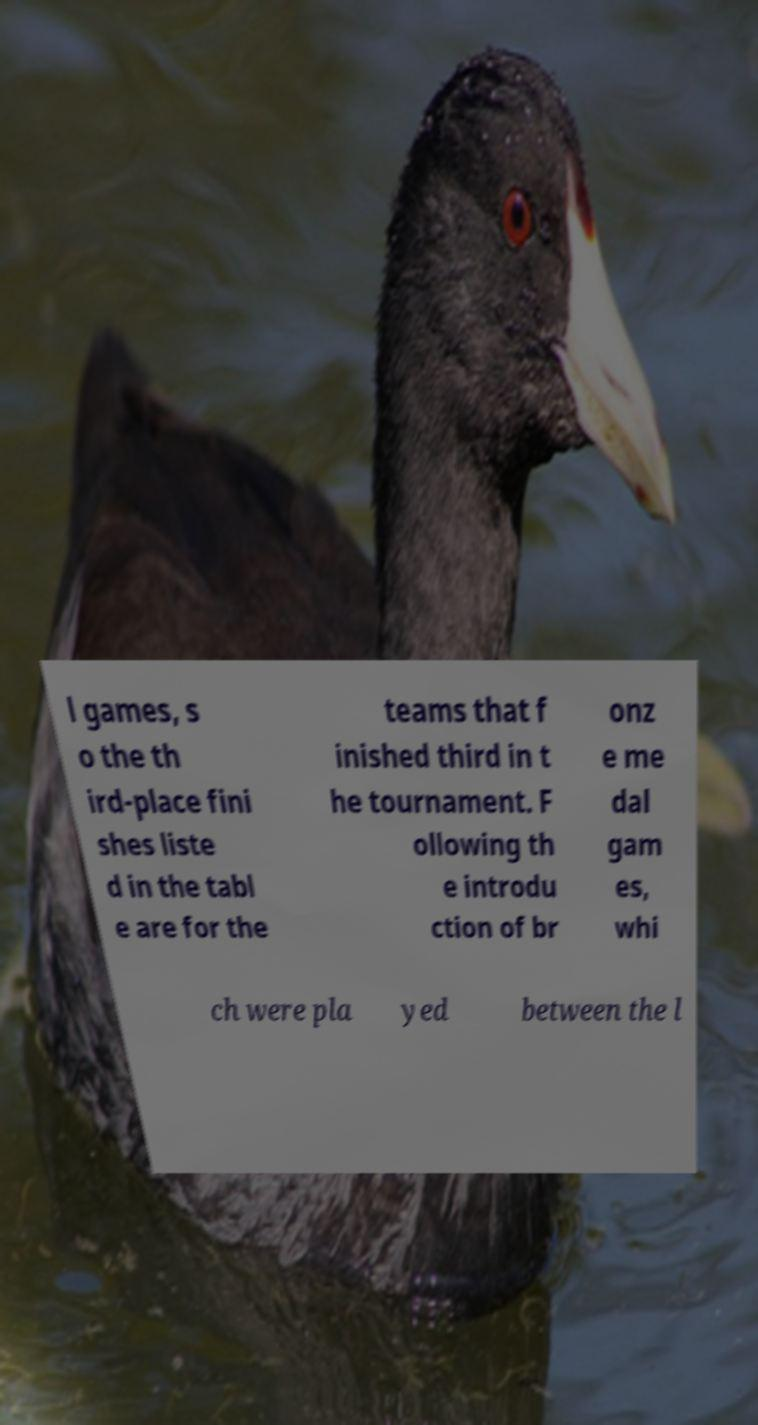What messages or text are displayed in this image? I need them in a readable, typed format. l games, s o the th ird-place fini shes liste d in the tabl e are for the teams that f inished third in t he tournament. F ollowing th e introdu ction of br onz e me dal gam es, whi ch were pla yed between the l 